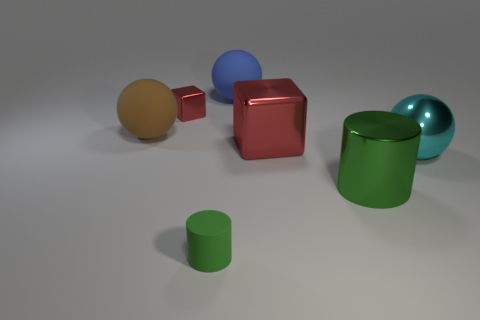Add 3 purple matte cylinders. How many objects exist? 10 Subtract all spheres. How many objects are left? 4 Add 4 big brown rubber things. How many big brown rubber things are left? 5 Add 2 large red cubes. How many large red cubes exist? 3 Subtract 0 yellow cylinders. How many objects are left? 7 Subtract all tiny green cylinders. Subtract all small green matte cylinders. How many objects are left? 5 